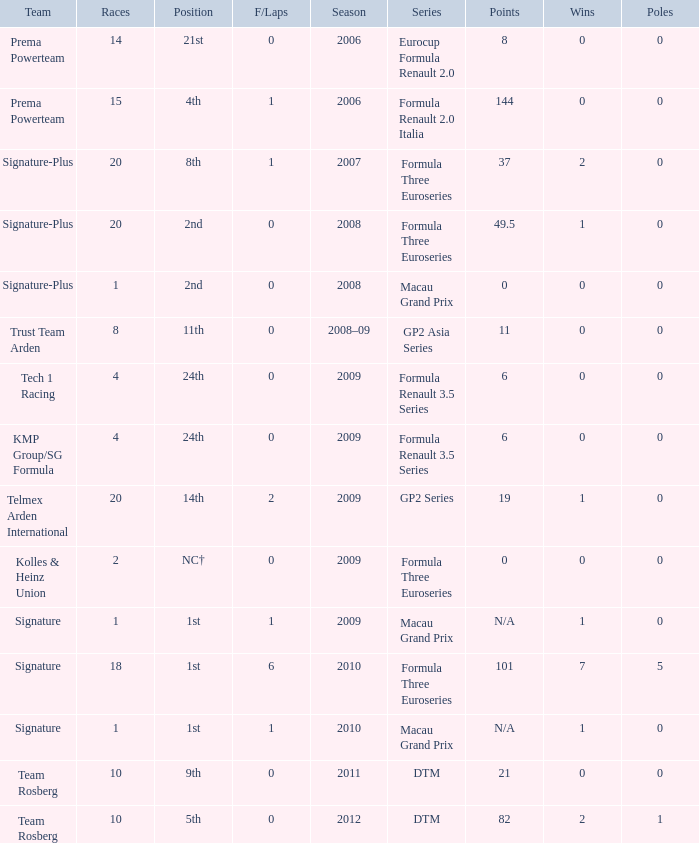Which series has 11 points? GP2 Asia Series. 